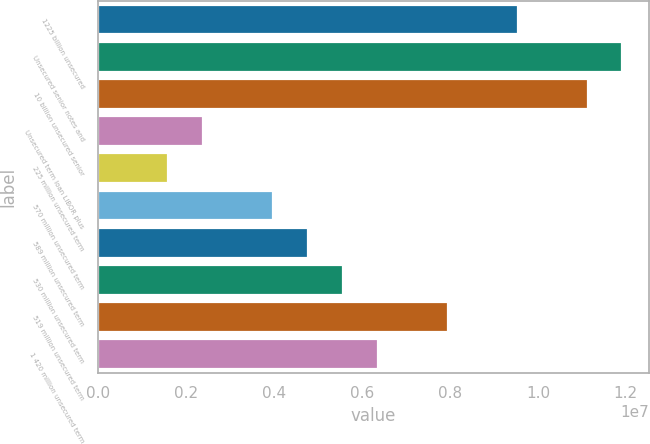Convert chart. <chart><loc_0><loc_0><loc_500><loc_500><bar_chart><fcel>1225 billion unsecured<fcel>Unsecured senior notes and<fcel>10 billion unsecured senior<fcel>Unsecured term loan LIBOR plus<fcel>225 million unsecured term<fcel>570 million unsecured term<fcel>589 million unsecured term<fcel>530 million unsecured term<fcel>519 million unsecured term<fcel>1 420 million unsecured term<nl><fcel>9.54008e+06<fcel>1.19234e+07<fcel>1.1129e+07<fcel>2.39006e+06<fcel>1.59561e+06<fcel>3.97895e+06<fcel>4.7734e+06<fcel>5.56785e+06<fcel>7.95119e+06<fcel>6.36229e+06<nl></chart> 